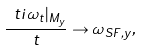<formula> <loc_0><loc_0><loc_500><loc_500>\frac { \ t i { \omega } _ { t } | _ { M _ { y } } } { t } \to \omega _ { S F , y } ,</formula> 